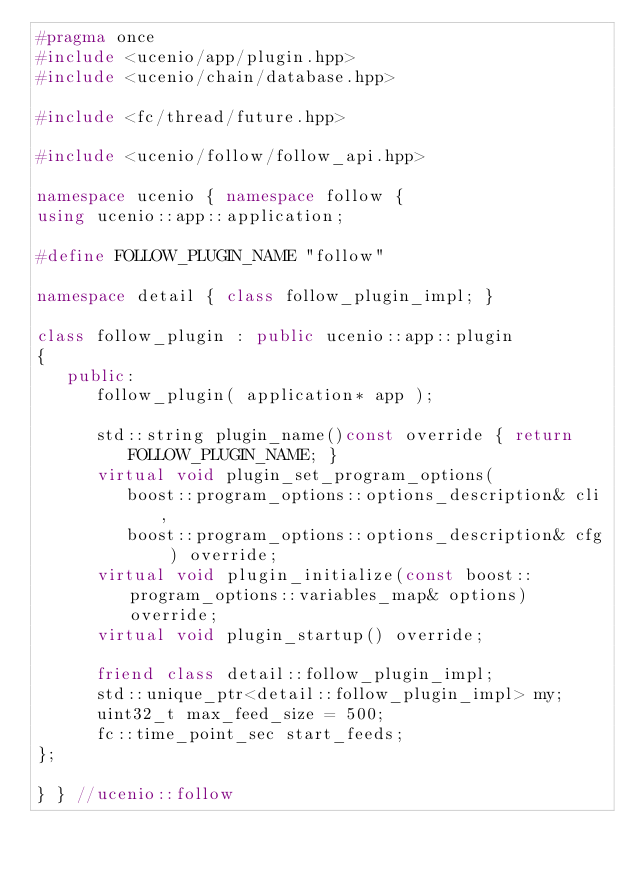Convert code to text. <code><loc_0><loc_0><loc_500><loc_500><_C++_>#pragma once
#include <ucenio/app/plugin.hpp>
#include <ucenio/chain/database.hpp>

#include <fc/thread/future.hpp>

#include <ucenio/follow/follow_api.hpp>

namespace ucenio { namespace follow {
using ucenio::app::application;

#define FOLLOW_PLUGIN_NAME "follow"

namespace detail { class follow_plugin_impl; }

class follow_plugin : public ucenio::app::plugin
{
   public:
      follow_plugin( application* app );

      std::string plugin_name()const override { return FOLLOW_PLUGIN_NAME; }
      virtual void plugin_set_program_options(
         boost::program_options::options_description& cli,
         boost::program_options::options_description& cfg ) override;
      virtual void plugin_initialize(const boost::program_options::variables_map& options) override;
      virtual void plugin_startup() override;

      friend class detail::follow_plugin_impl;
      std::unique_ptr<detail::follow_plugin_impl> my;
      uint32_t max_feed_size = 500;
      fc::time_point_sec start_feeds;
};

} } //ucenio::follow
</code> 